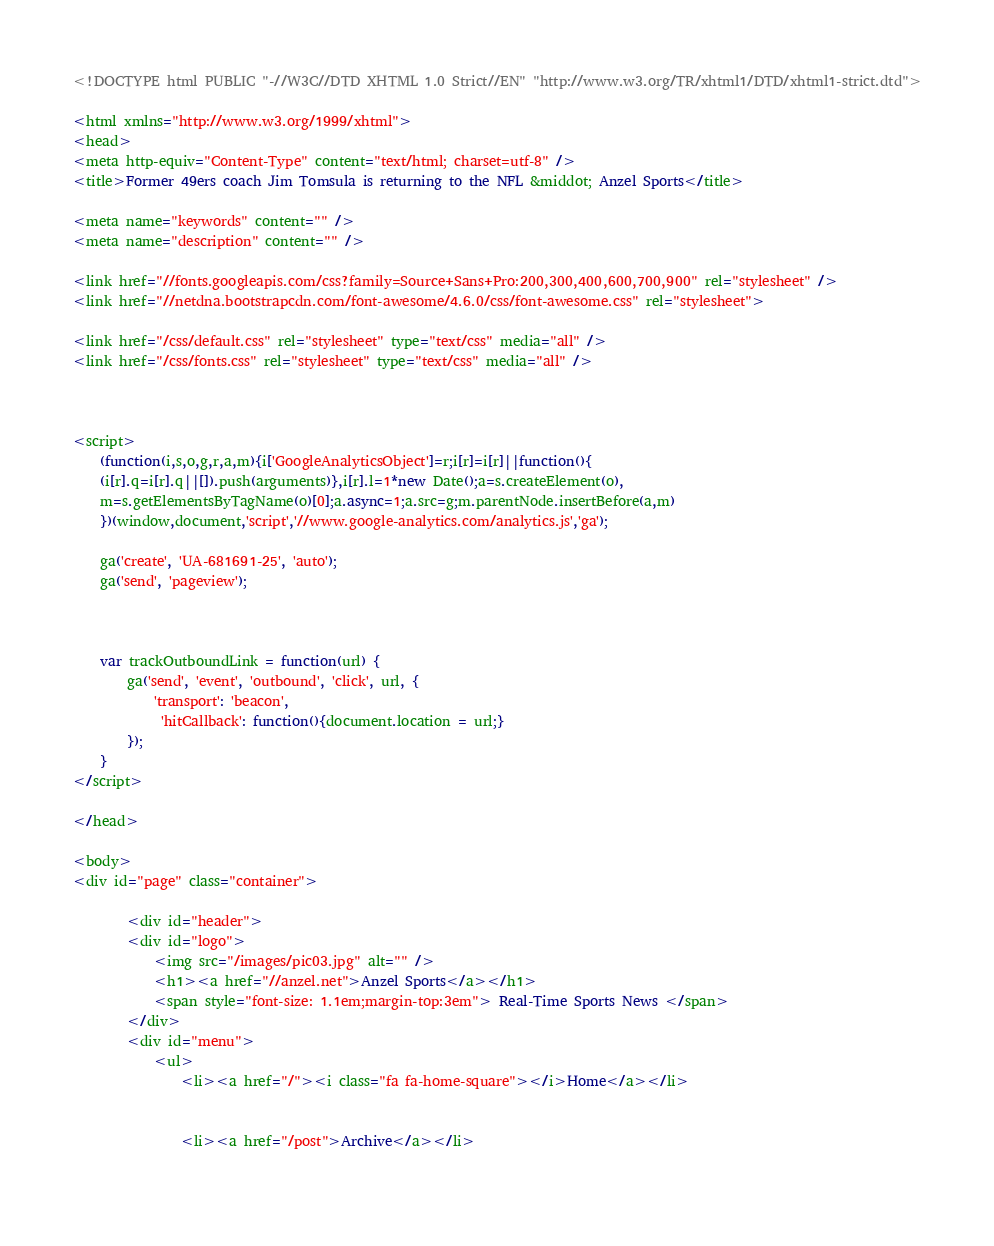<code> <loc_0><loc_0><loc_500><loc_500><_HTML_><!DOCTYPE html PUBLIC "-//W3C//DTD XHTML 1.0 Strict//EN" "http://www.w3.org/TR/xhtml1/DTD/xhtml1-strict.dtd">

<html xmlns="http://www.w3.org/1999/xhtml">
<head>
<meta http-equiv="Content-Type" content="text/html; charset=utf-8" />
<title>Former 49ers coach Jim Tomsula is returning to the NFL &middot; Anzel Sports</title>

<meta name="keywords" content="" />
<meta name="description" content="" />

<link href="//fonts.googleapis.com/css?family=Source+Sans+Pro:200,300,400,600,700,900" rel="stylesheet" />
<link href="//netdna.bootstrapcdn.com/font-awesome/4.6.0/css/font-awesome.css" rel="stylesheet">

<link href="/css/default.css" rel="stylesheet" type="text/css" media="all" />
<link href="/css/fonts.css" rel="stylesheet" type="text/css" media="all" />



<script>
	(function(i,s,o,g,r,a,m){i['GoogleAnalyticsObject']=r;i[r]=i[r]||function(){
	(i[r].q=i[r].q||[]).push(arguments)},i[r].l=1*new Date();a=s.createElement(o),
	m=s.getElementsByTagName(o)[0];a.async=1;a.src=g;m.parentNode.insertBefore(a,m)
	})(window,document,'script','//www.google-analytics.com/analytics.js','ga');

	ga('create', 'UA-681691-25', 'auto');
	ga('send', 'pageview');

	

	var trackOutboundLink = function(url) {
		ga('send', 'event', 'outbound', 'click', url, {
	        'transport': 'beacon',
		     'hitCallback': function(){document.location = url;}
	    });
	}
</script>

</head>

<body>
<div id="page" class="container">

		<div id="header">
		<div id="logo">
			<img src="/images/pic03.jpg" alt="" />
			<h1><a href="//anzel.net">Anzel Sports</a></h1>
			<span style="font-size: 1.1em;margin-top:3em"> Real-Time Sports News </span>
		</div>
		<div id="menu">
			<ul>
				<li><a href="/"><i class="fa fa-home-square"></i>Home</a></li>

				
				<li><a href="/post">Archive</a></li>
				</code> 